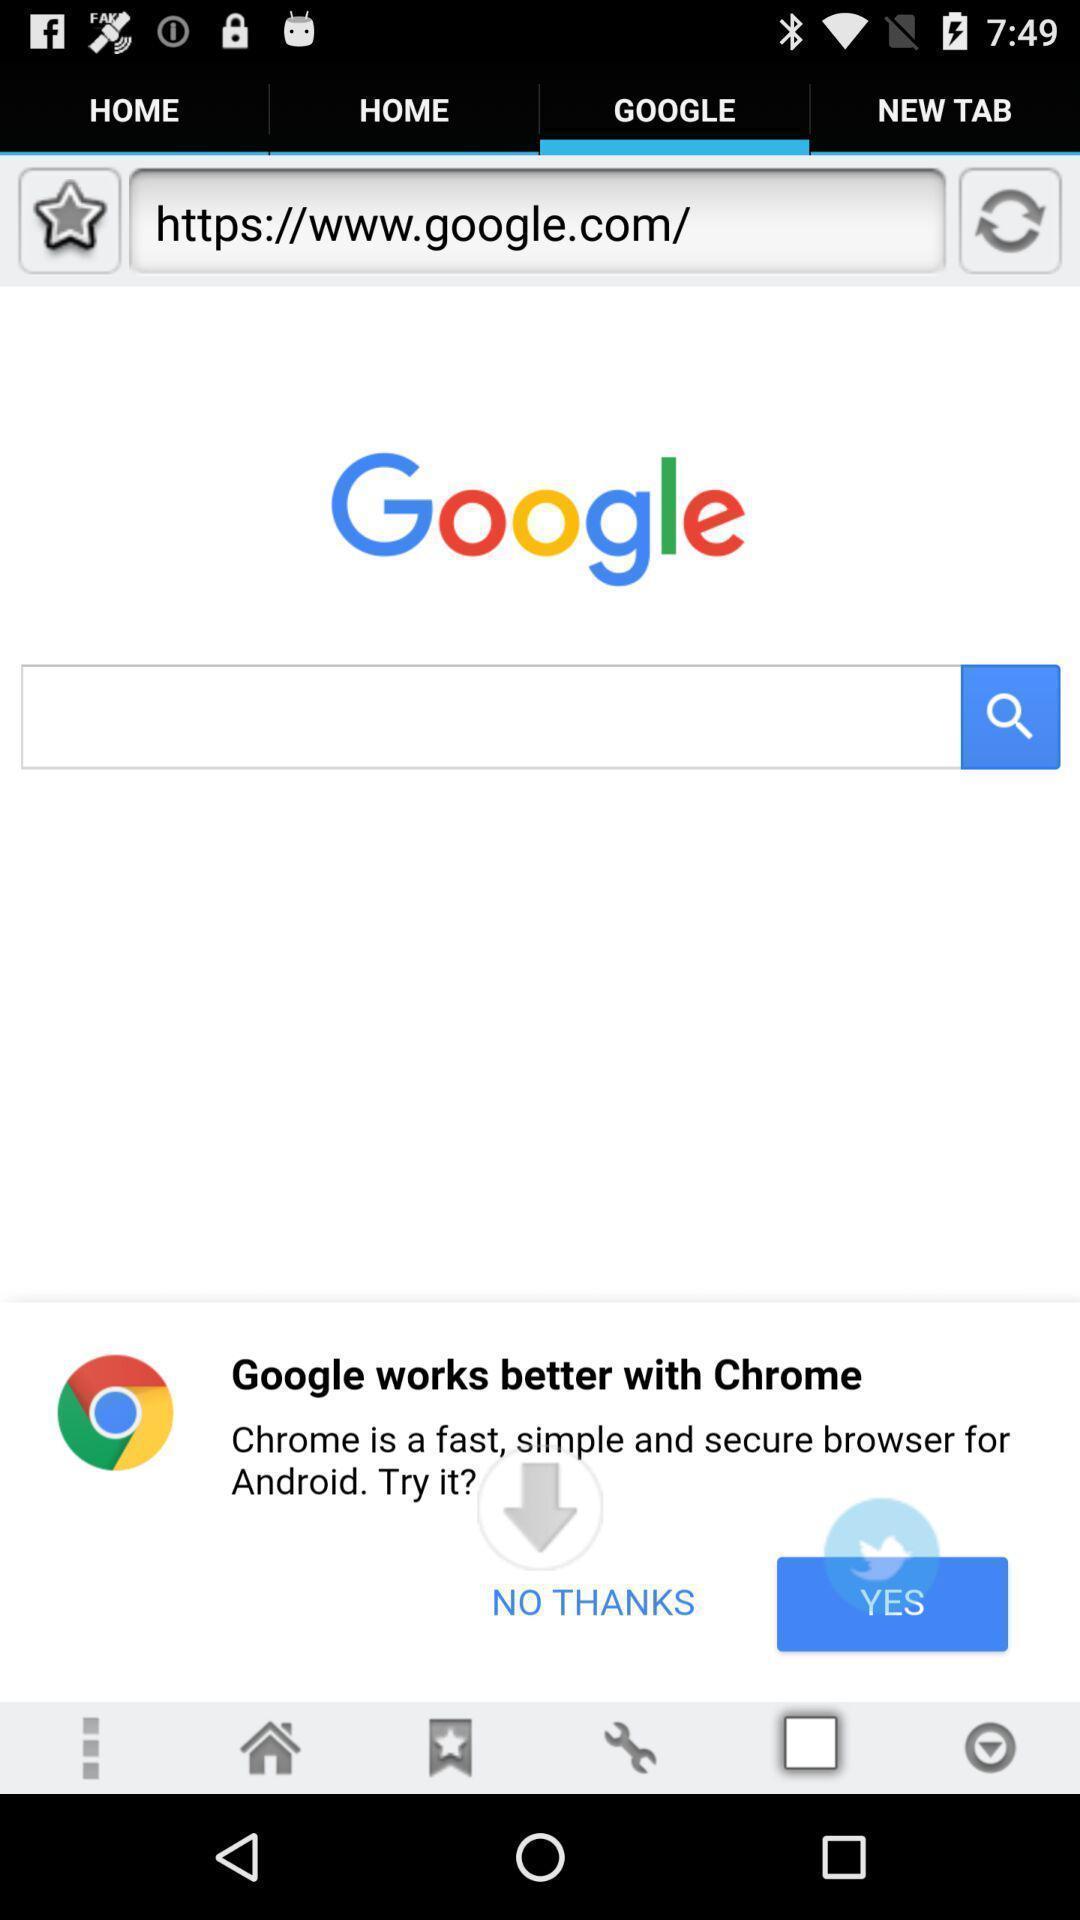Summarize the main components in this picture. Search page displaying of an browsing application. 